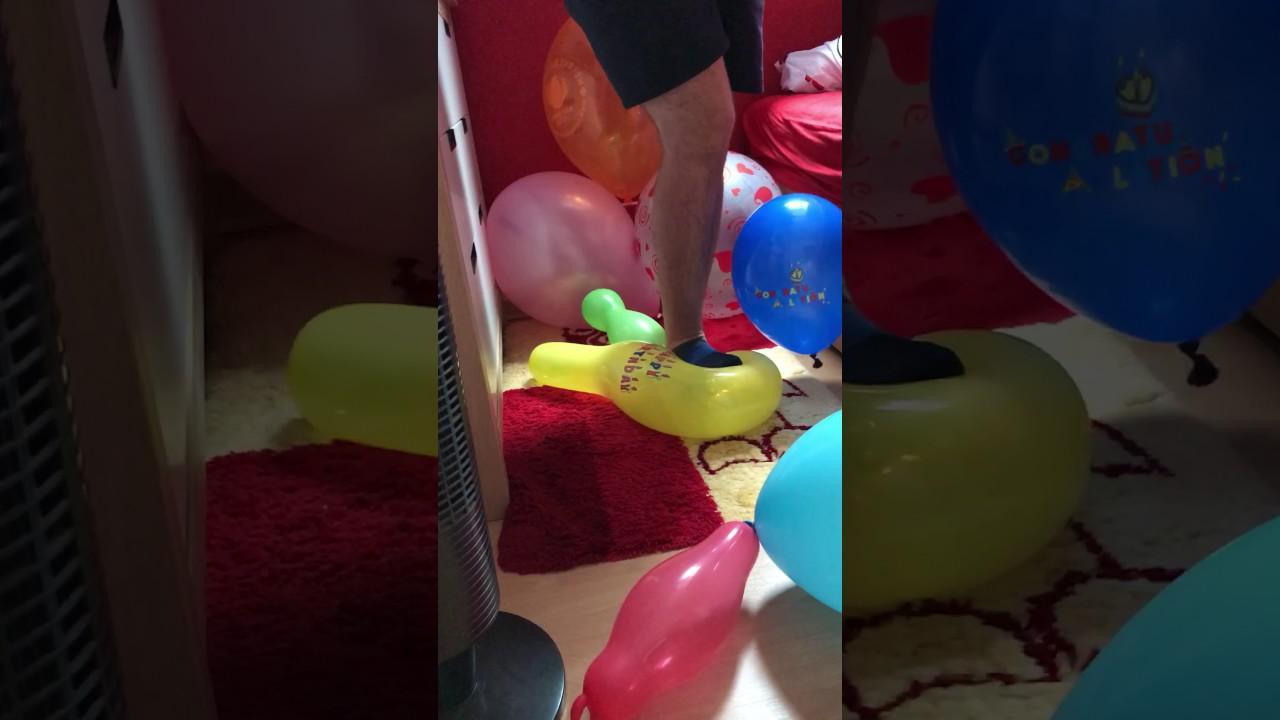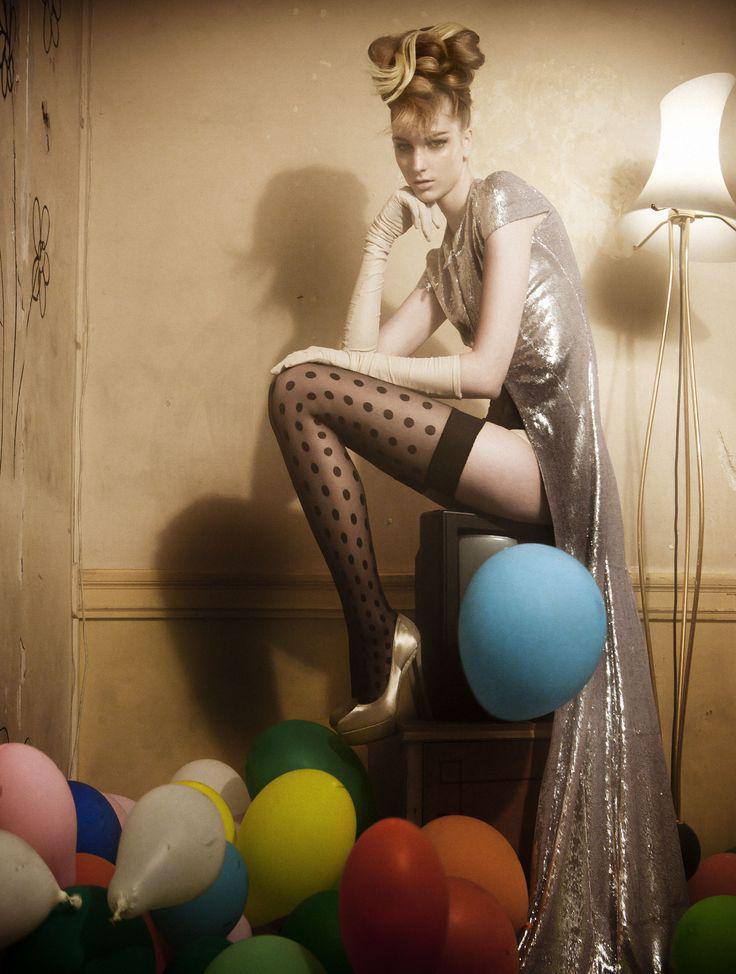The first image is the image on the left, the second image is the image on the right. Evaluate the accuracy of this statement regarding the images: "In at least one image there is a woman with a pair of high heels above a balloon.". Is it true? Answer yes or no. Yes. 